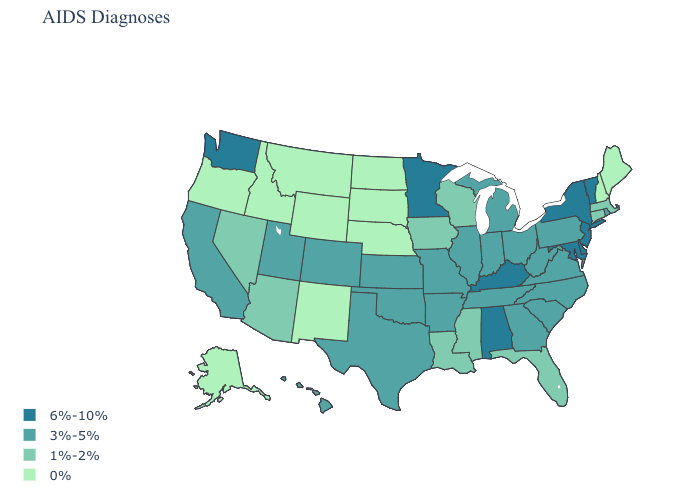How many symbols are there in the legend?
Write a very short answer. 4. Which states have the highest value in the USA?
Write a very short answer. Alabama, Delaware, Kentucky, Maryland, Minnesota, New Jersey, New York, Vermont, Washington. Name the states that have a value in the range 6%-10%?
Concise answer only. Alabama, Delaware, Kentucky, Maryland, Minnesota, New Jersey, New York, Vermont, Washington. Name the states that have a value in the range 0%?
Give a very brief answer. Alaska, Idaho, Maine, Montana, Nebraska, New Hampshire, New Mexico, North Dakota, Oregon, South Dakota, Wyoming. What is the value of Washington?
Write a very short answer. 6%-10%. Among the states that border Delaware , which have the highest value?
Answer briefly. Maryland, New Jersey. Name the states that have a value in the range 3%-5%?
Answer briefly. Arkansas, California, Colorado, Georgia, Hawaii, Illinois, Indiana, Kansas, Michigan, Missouri, North Carolina, Ohio, Oklahoma, Pennsylvania, Rhode Island, South Carolina, Tennessee, Texas, Utah, Virginia, West Virginia. Does Utah have a higher value than North Carolina?
Answer briefly. No. What is the value of New Jersey?
Keep it brief. 6%-10%. What is the lowest value in the Northeast?
Keep it brief. 0%. Is the legend a continuous bar?
Concise answer only. No. What is the highest value in states that border Minnesota?
Short answer required. 1%-2%. Among the states that border New Hampshire , which have the lowest value?
Quick response, please. Maine. What is the lowest value in the Northeast?
Be succinct. 0%. Name the states that have a value in the range 1%-2%?
Keep it brief. Arizona, Connecticut, Florida, Iowa, Louisiana, Massachusetts, Mississippi, Nevada, Wisconsin. 